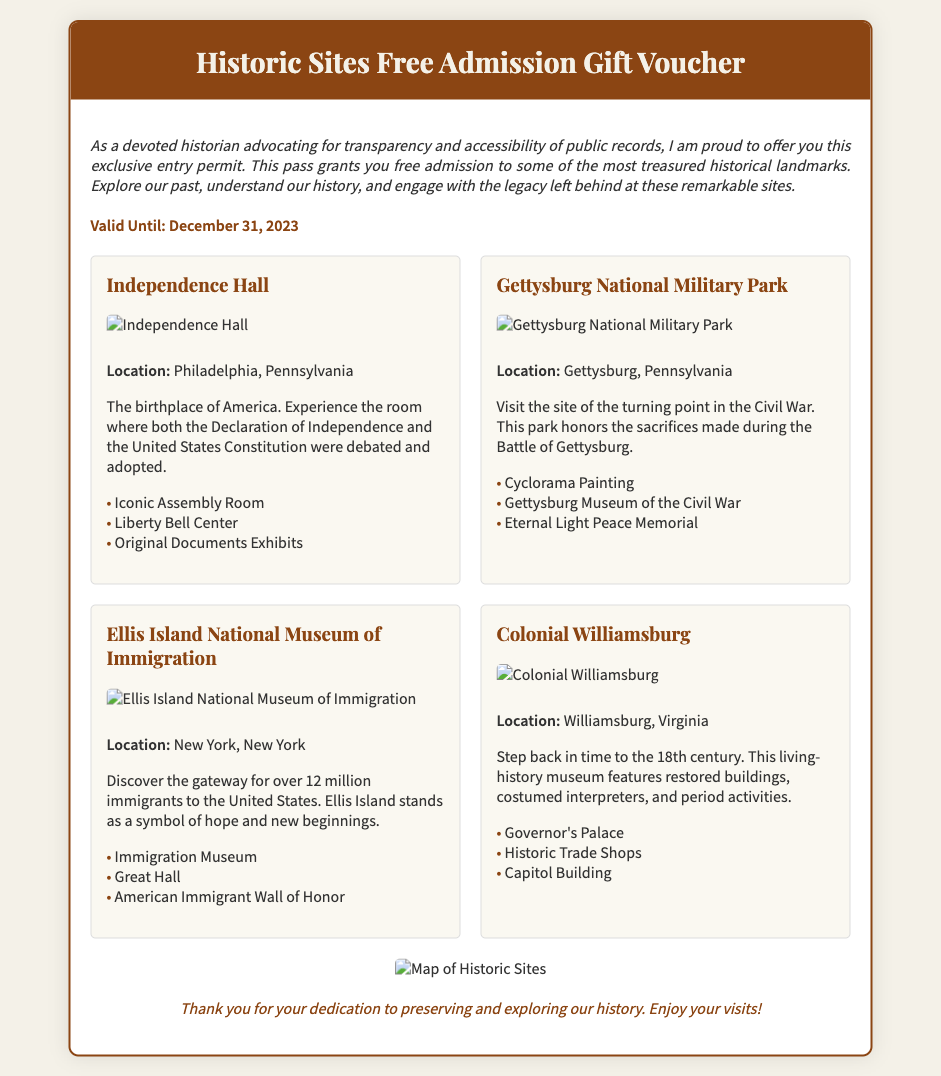What is the title of the voucher? The title of the voucher is prominently displayed at the top of the document.
Answer: Historic Sites Free Admission Gift Voucher What is the validity date of the voucher? The validity date is noted clearly in the document, specifying how long the voucher can be used.
Answer: December 31, 2023 How many historical sites are included in the voucher? The voucher lists several historical sites within its content.
Answer: Four Where is Independence Hall located? The document specifies the location of Independence Hall in its description.
Answer: Philadelphia, Pennsylvania What is the highlight feature of Ellis Island? The document mentions several highlights of each site.
Answer: Immigration Museum Which site allows visitors to experience the 18th century? The document describes a site known for its living-history experiences.
Answer: Colonial Williamsburg What type of voucher is this? The document outlines an entry permit for visiting historical landmarks.
Answer: Gift voucher What does the footer of the document express? The footer summarizes the purpose of the voucher and encourages historical exploration.
Answer: Thank you for your dedication to preserving and exploring our history. Enjoy your visits! 